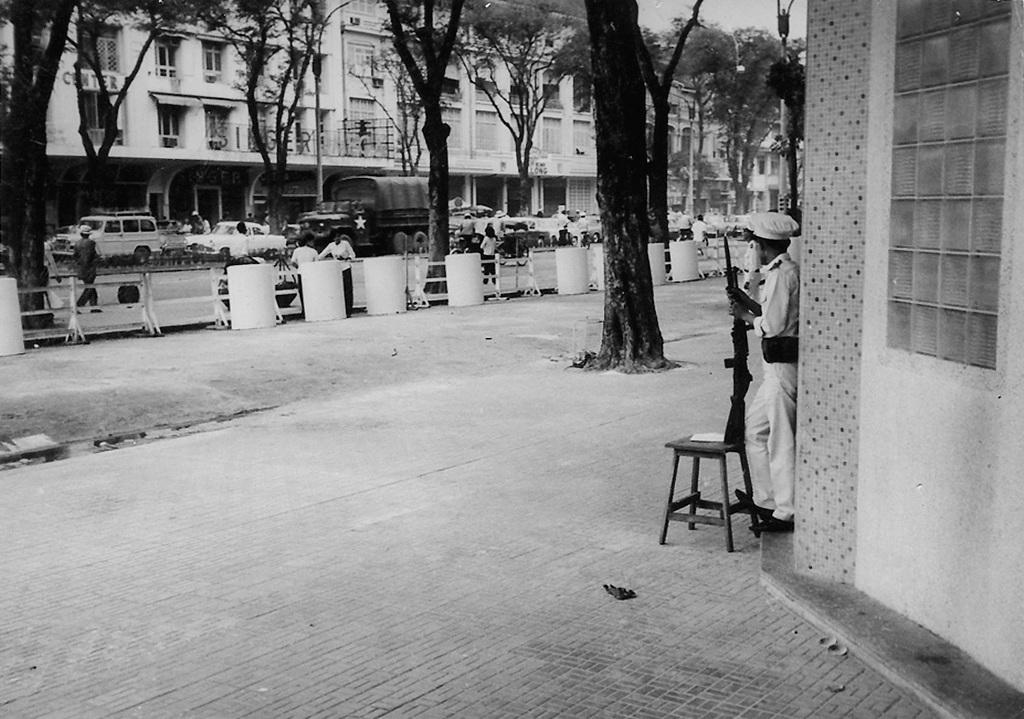How many persons are in the image? There are persons in the image. What else can be seen on the road in the image? There are vehicles on the road in the image. What type of vegetation is visible in the image? Trees are visible in the image. Can you describe the person holding a gun in the image? A person is holding a gun in the image. What type of structure is present in the image? There is a building in the image. What is on the right side of the image? There is a wall on the right side of the image. What type of paper is the bat reading in the image? There is no bat or paper present in the image. 